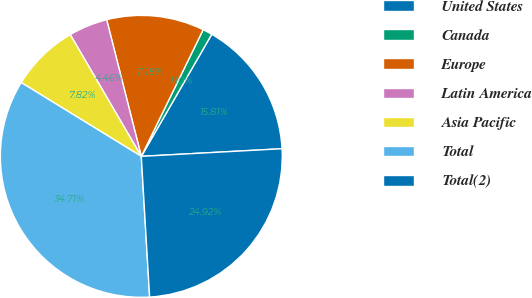Convert chart to OTSL. <chart><loc_0><loc_0><loc_500><loc_500><pie_chart><fcel>United States<fcel>Canada<fcel>Europe<fcel>Latin America<fcel>Asia Pacific<fcel>Total<fcel>Total(2)<nl><fcel>15.81%<fcel>1.1%<fcel>11.18%<fcel>4.46%<fcel>7.82%<fcel>34.71%<fcel>24.92%<nl></chart> 